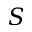Convert formula to latex. <formula><loc_0><loc_0><loc_500><loc_500>S</formula> 